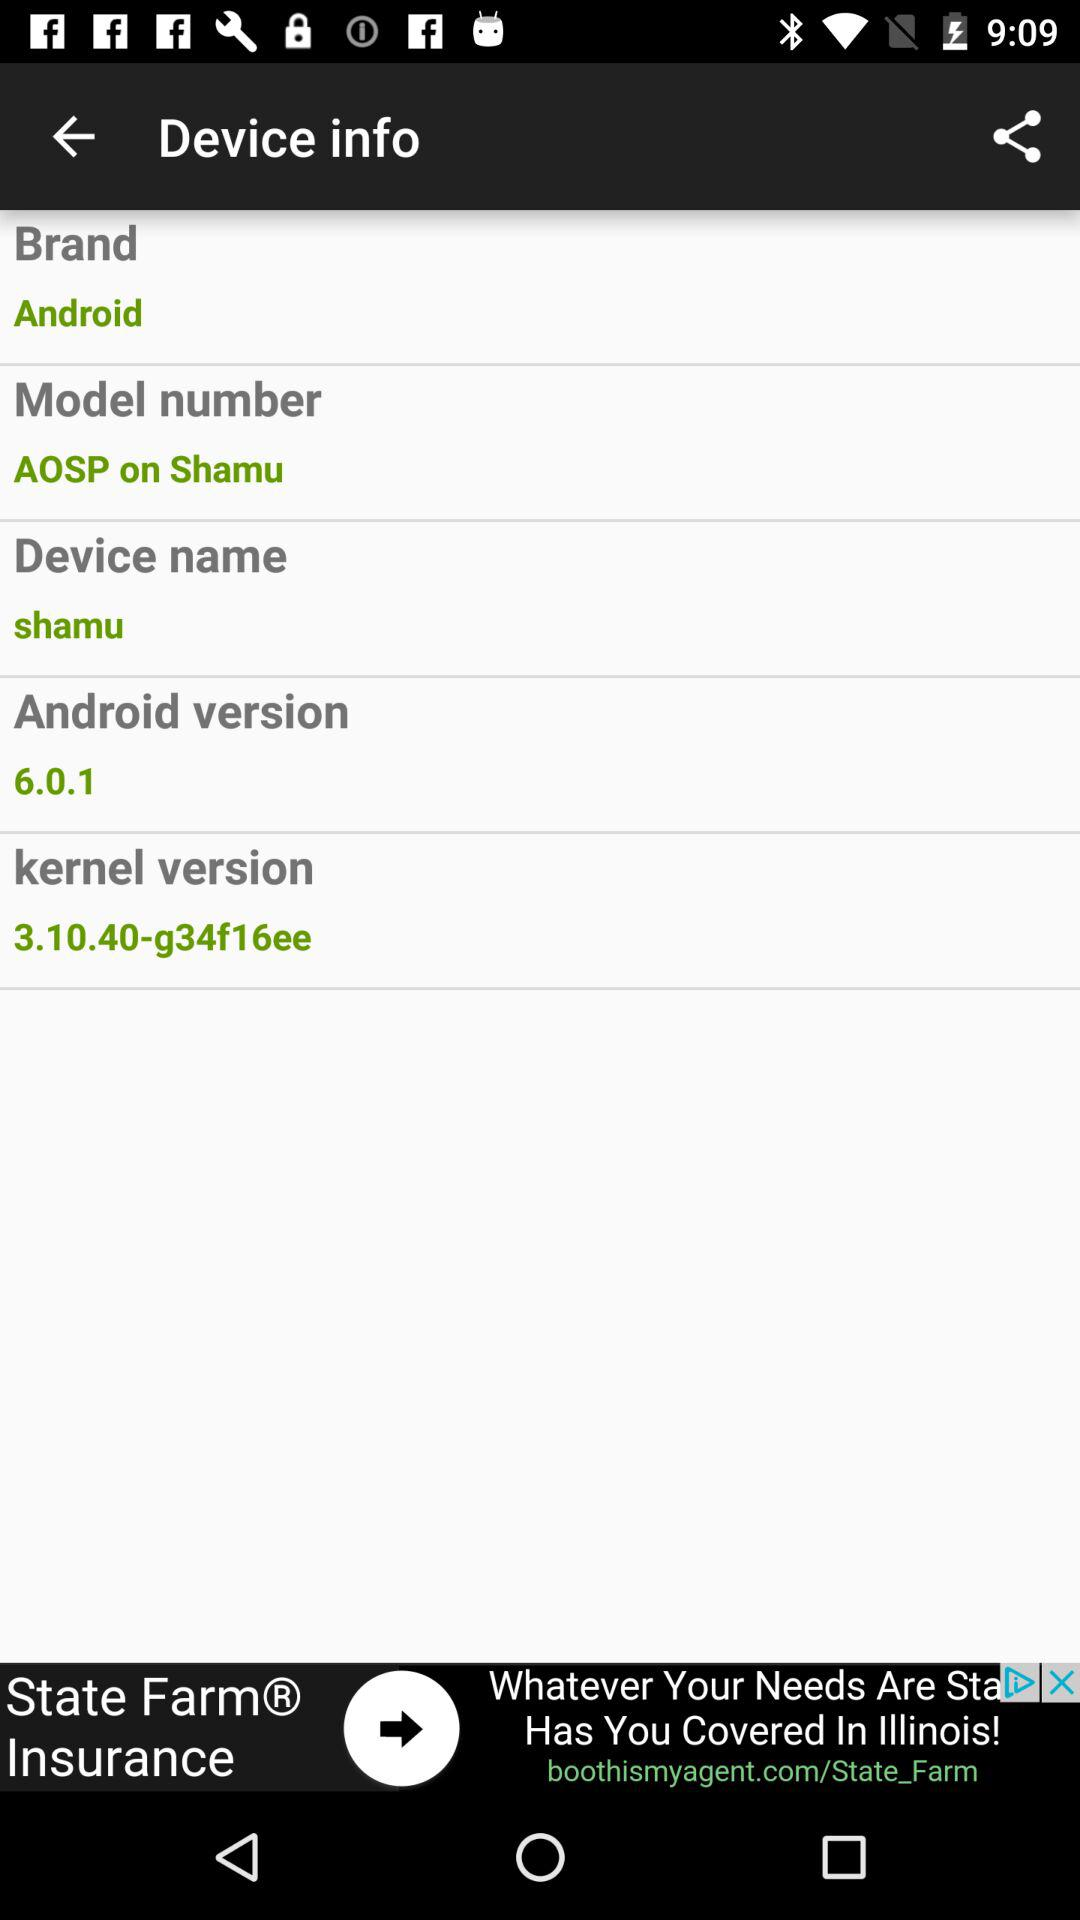What is the Android version? The Android version is 6.0.1. 